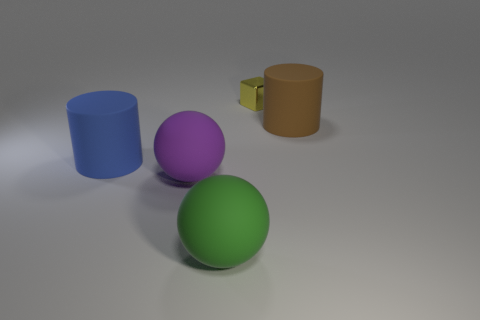Add 1 blue cylinders. How many objects exist? 6 Subtract all cubes. How many objects are left? 4 Add 1 large balls. How many large balls are left? 3 Add 5 gray metal things. How many gray metal things exist? 5 Subtract 0 gray cylinders. How many objects are left? 5 Subtract all large yellow matte cylinders. Subtract all green objects. How many objects are left? 4 